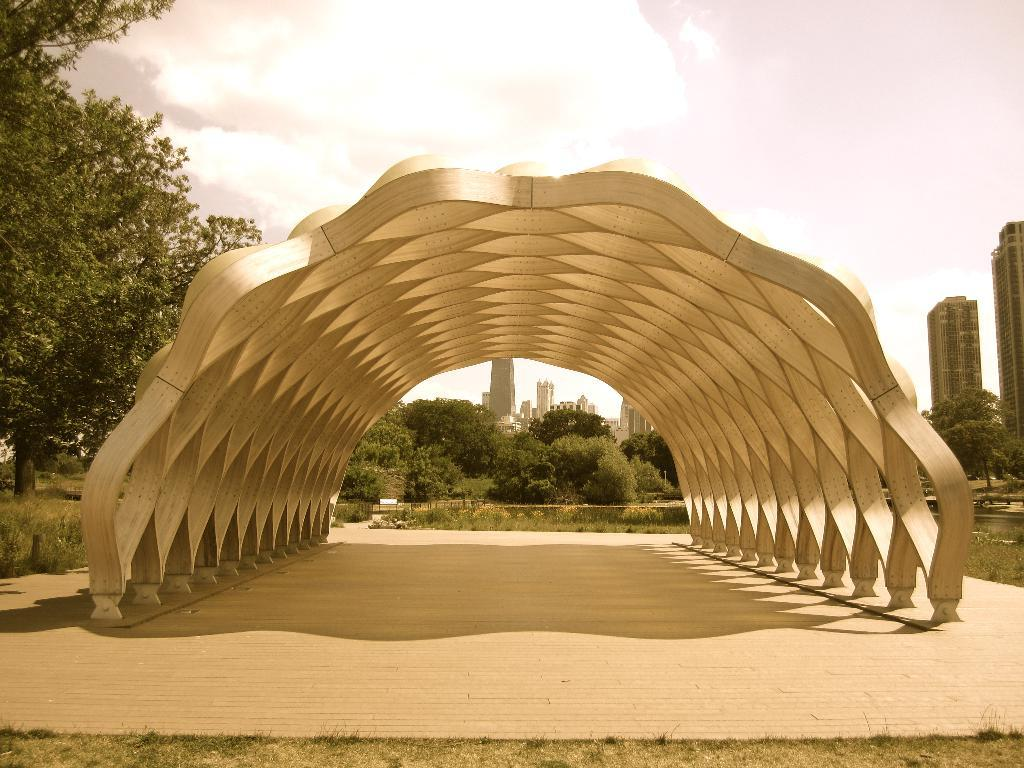What is the main subject in the center of the image? There is a nature boardwalk in the center of the image. What can be seen in the background of the image? The sky, clouds, trees, buildings, plants, and grass are visible in the background of the image. What type of instrument is being played by the tree in the image? There is no instrument being played by a tree in the image, as trees do not play musical instruments. 